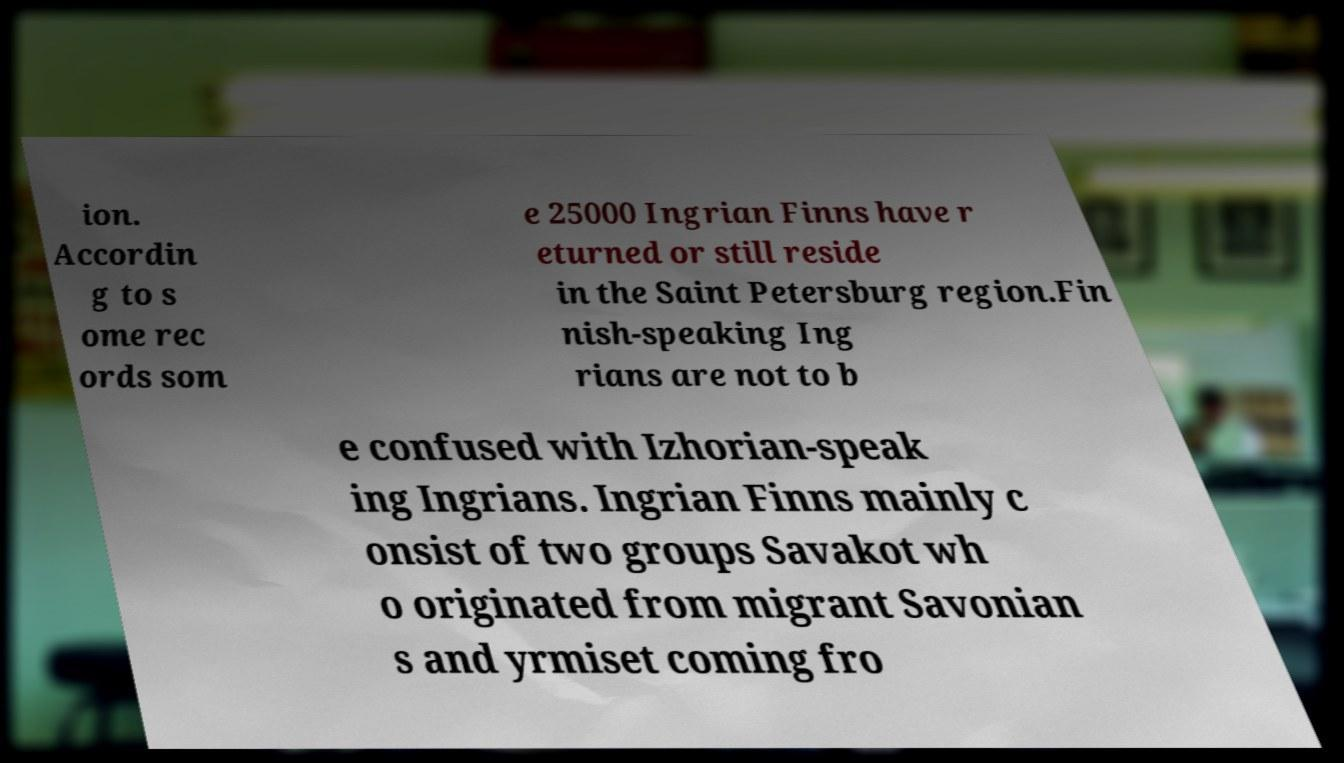Please identify and transcribe the text found in this image. ion. Accordin g to s ome rec ords som e 25000 Ingrian Finns have r eturned or still reside in the Saint Petersburg region.Fin nish-speaking Ing rians are not to b e confused with Izhorian-speak ing Ingrians. Ingrian Finns mainly c onsist of two groups Savakot wh o originated from migrant Savonian s and yrmiset coming fro 